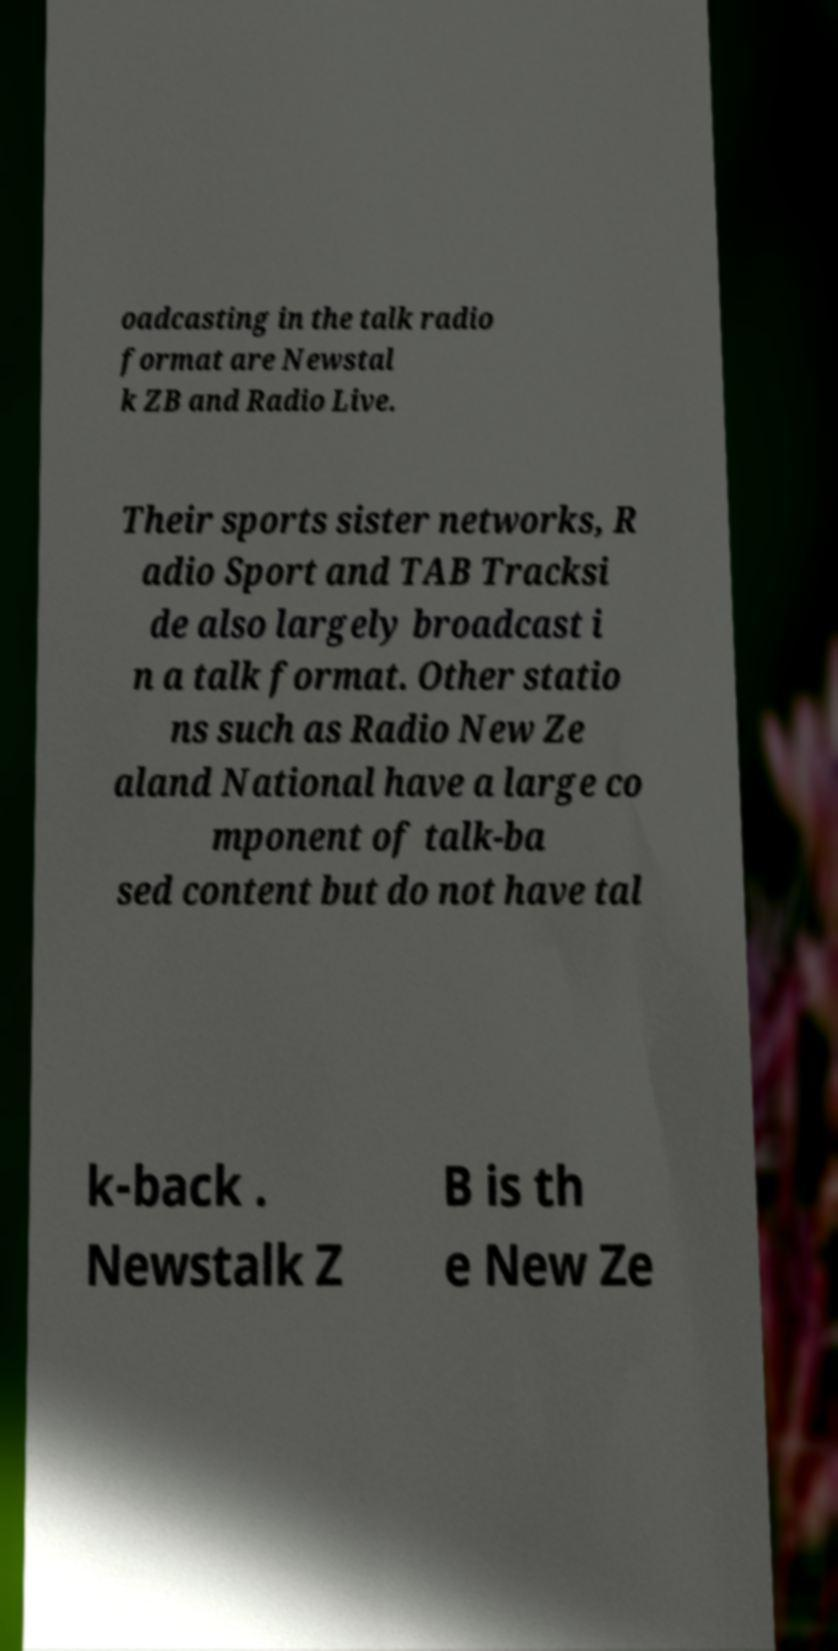Can you accurately transcribe the text from the provided image for me? oadcasting in the talk radio format are Newstal k ZB and Radio Live. Their sports sister networks, R adio Sport and TAB Tracksi de also largely broadcast i n a talk format. Other statio ns such as Radio New Ze aland National have a large co mponent of talk-ba sed content but do not have tal k-back . Newstalk Z B is th e New Ze 